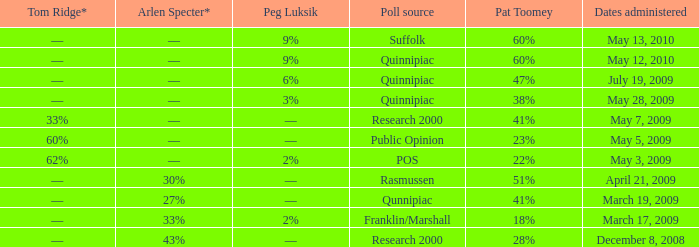Which Tom Ridge* has a Pat Toomey of 60%, and a Poll source of suffolk? ––. 